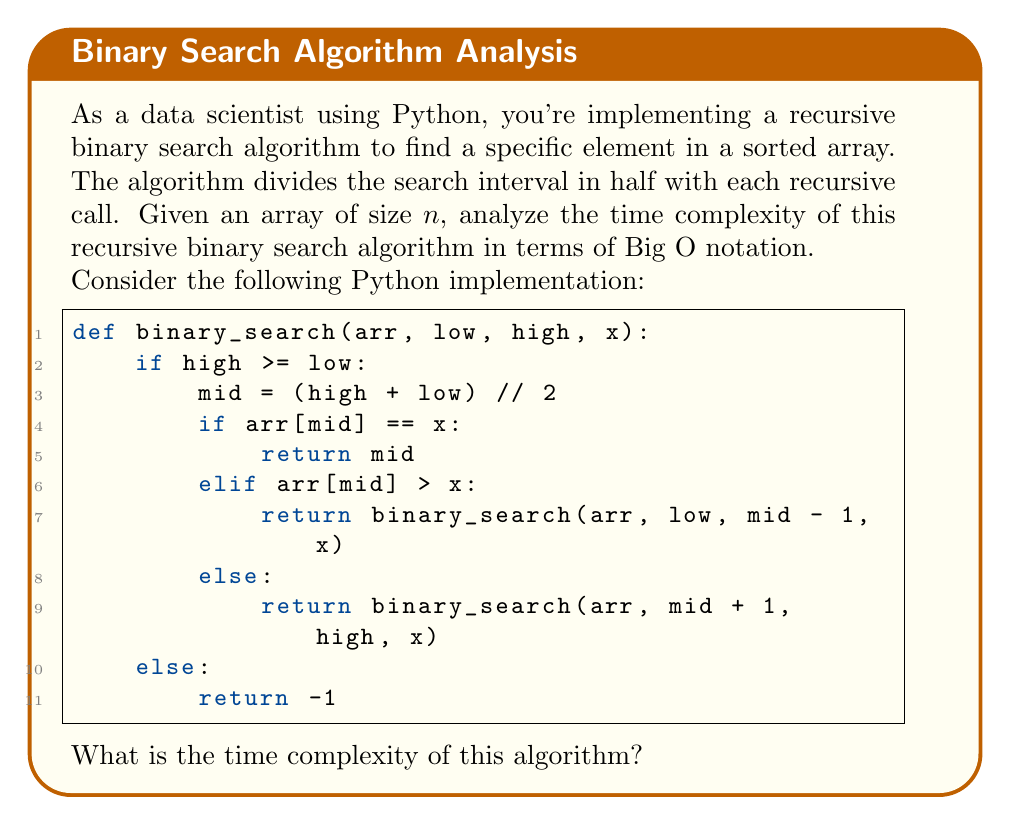Teach me how to tackle this problem. To analyze the time complexity of the recursive binary search algorithm, we need to consider the following steps:

1) In each recursive call, the algorithm performs constant time operations (comparisons and arithmetic), which we can consider as $O(1)$.

2) The key aspect of binary search is that it divides the search space in half with each recursive call. This means that for an array of size $n$, the number of elements to search is reduced by half in each step:

   $n \rightarrow \frac{n}{2} \rightarrow \frac{n}{4} \rightarrow \frac{n}{8} \rightarrow ...$

3) We need to determine how many times we can divide $n$ by 2 before reaching 1 (as the base case is when the search space is reduced to a single element or empty). This is equivalent to solving the equation:

   $$\frac{n}{2^k} = 1$$

4) Solving for $k$:
   
   $$n = 2^k$$
   $$\log_2(n) = k$$

5) This means that the maximum number of recursive calls (or the depth of the recursion tree) is $\log_2(n)$.

6) Since each recursive call performs $O(1)$ operations, and there are at most $\log_2(n)$ recursive calls, the overall time complexity is:

   $$O(\log n)$$

It's worth noting that this is the same time complexity as the iterative version of binary search, but the recursive version may have additional space complexity due to the call stack.
Answer: $O(\log n)$ 